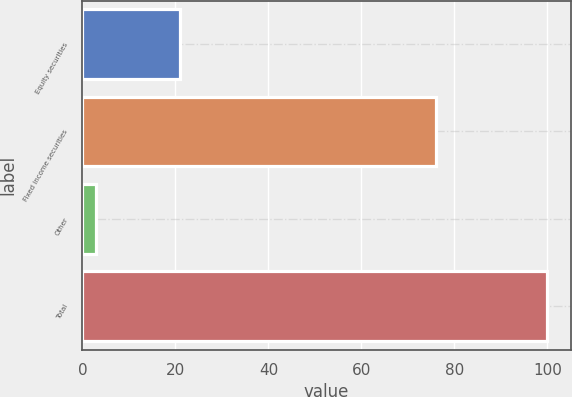Convert chart. <chart><loc_0><loc_0><loc_500><loc_500><bar_chart><fcel>Equity securities<fcel>Fixed income securities<fcel>Other<fcel>Total<nl><fcel>21<fcel>76<fcel>3<fcel>100<nl></chart> 